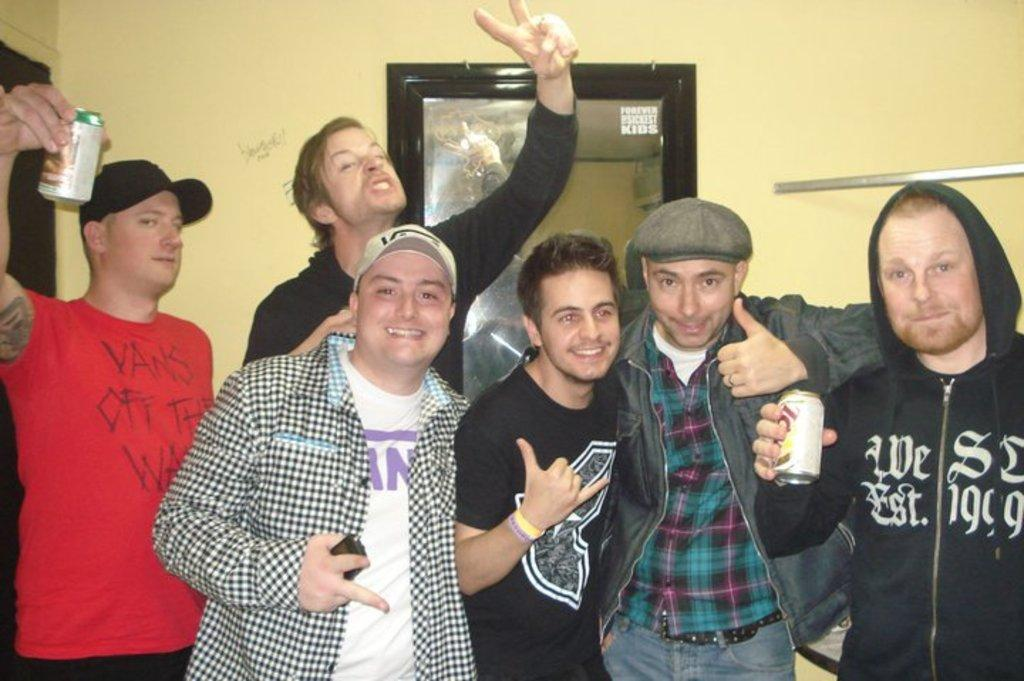<image>
Describe the image concisely. a group of people standing for a picture with one wearing a shirt that says 'vans' 